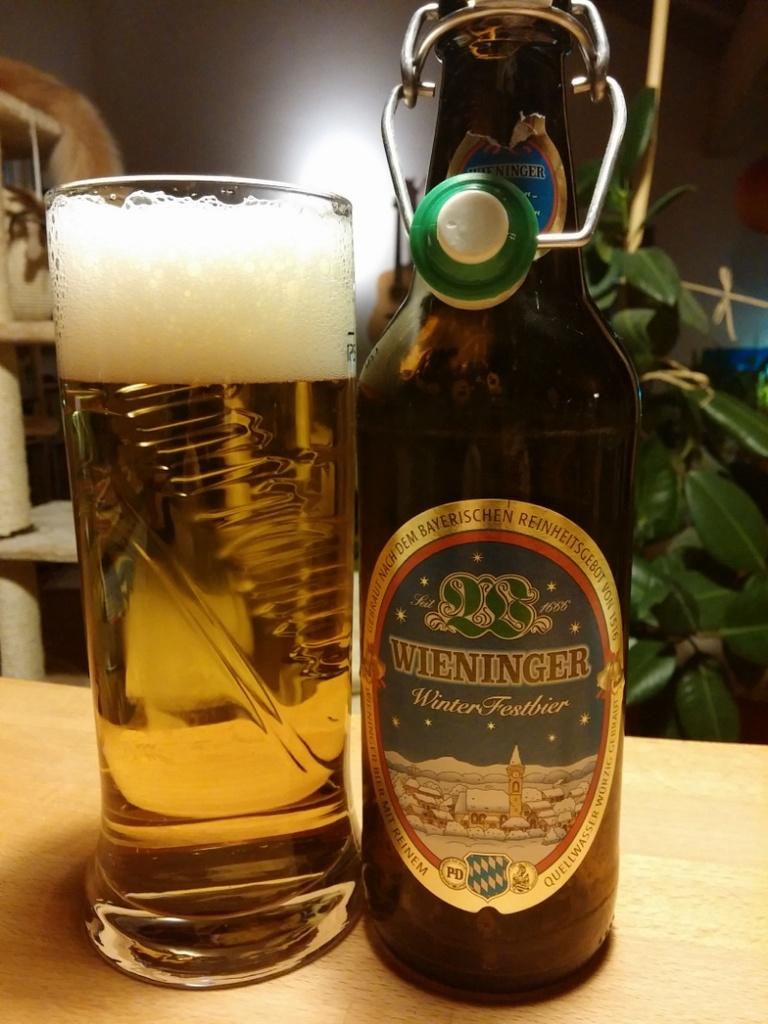What is the brand name of the beer?
Make the answer very short. Wieninger. What kind of drink is this?
Your answer should be compact. Answering does not require reading text in the image. 